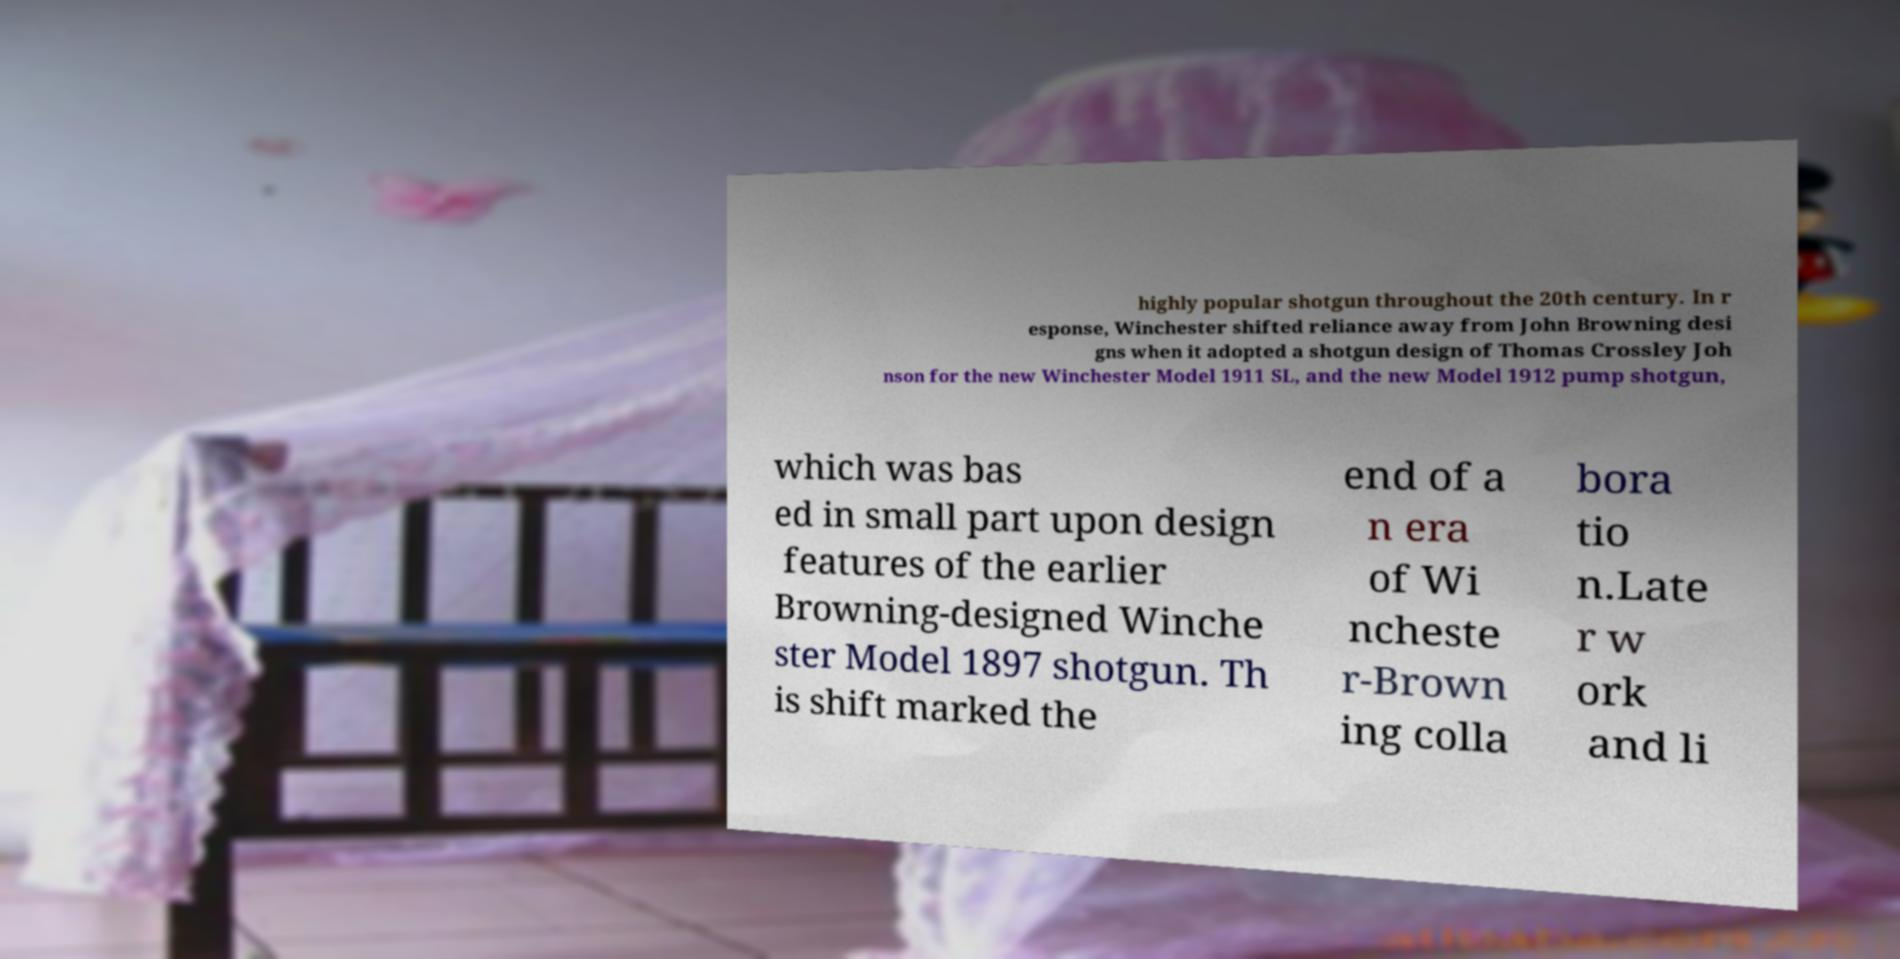I need the written content from this picture converted into text. Can you do that? highly popular shotgun throughout the 20th century. In r esponse, Winchester shifted reliance away from John Browning desi gns when it adopted a shotgun design of Thomas Crossley Joh nson for the new Winchester Model 1911 SL, and the new Model 1912 pump shotgun, which was bas ed in small part upon design features of the earlier Browning-designed Winche ster Model 1897 shotgun. Th is shift marked the end of a n era of Wi ncheste r-Brown ing colla bora tio n.Late r w ork and li 